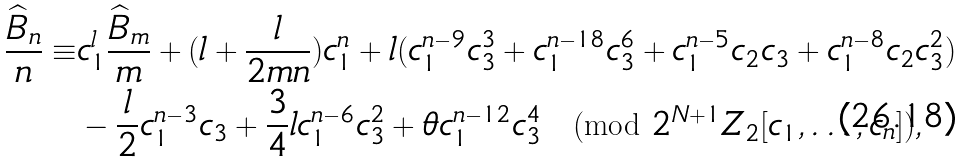Convert formula to latex. <formula><loc_0><loc_0><loc_500><loc_500>\frac { \widehat { B } _ { n } } { n } \equiv & c _ { 1 } ^ { l } \frac { \widehat { B } _ { m } } { m } + ( l + \frac { l } { 2 m n } ) c _ { 1 } ^ { n } + l ( c _ { 1 } ^ { n - 9 } c _ { 3 } ^ { 3 } + c _ { 1 } ^ { n - 1 8 } c _ { 3 } ^ { 6 } + c _ { 1 } ^ { n - 5 } c _ { 2 } c _ { 3 } + c _ { 1 } ^ { n - 8 } c _ { 2 } c _ { 3 } ^ { 2 } ) \\ & - \frac { l } { 2 } c _ { 1 } ^ { n - 3 } c _ { 3 } + \frac { 3 } { 4 } l c _ { 1 } ^ { n - 6 } c _ { 3 } ^ { 2 } + \theta c _ { 1 } ^ { n - 1 2 } c _ { 3 } ^ { 4 } \pmod { 2 ^ { N + 1 } Z _ { 2 } [ c _ { 1 } , \dots , c _ { n } ] } ,</formula> 